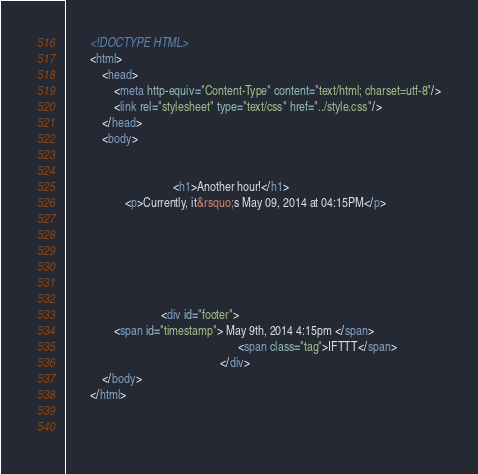<code> <loc_0><loc_0><loc_500><loc_500><_HTML_>        <!DOCTYPE HTML>
        <html>
            <head>
                <meta http-equiv="Content-Type" content="text/html; charset=utf-8"/>
                <link rel="stylesheet" type="text/css" href="../style.css"/>
            </head>
            <body>
                
                
                                    <h1>Another hour!</h1>
                    <p>Currently, it&rsquo;s May 09, 2014 at 04:15PM</p>
                
                
                
                
                
                
                                <div id="footer">
                <span id="timestamp"> May 9th, 2014 4:15pm </span>
                                                          <span class="tag">IFTTT</span>
                                                    </div>
            </body>
        </html>

        </code> 